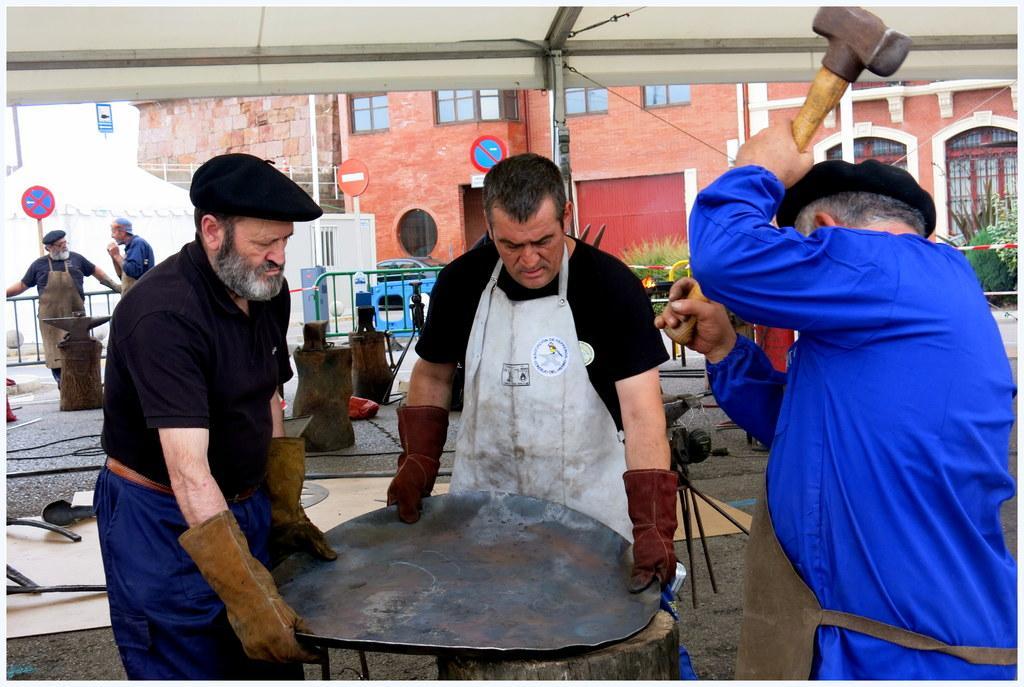How would you summarize this image in a sentence or two? In this picture on the right side, we can see a man wearing a blue color shirt and he is also holding hammer in his hands. In the middle of the image, we can see two people are standing and they are also holding metal plate on their hands. On the left side, we can also see two people are standing on the floor. In the background, we can also see a car, plants, flowers, buildings, glass window, hoardings, at the bottom, we can see some pillars, mat, electric wires. 